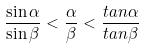Convert formula to latex. <formula><loc_0><loc_0><loc_500><loc_500>\frac { \sin \alpha } { \sin \beta } < \frac { \alpha } { \beta } < \frac { t a n \alpha } { t a n \beta }</formula> 